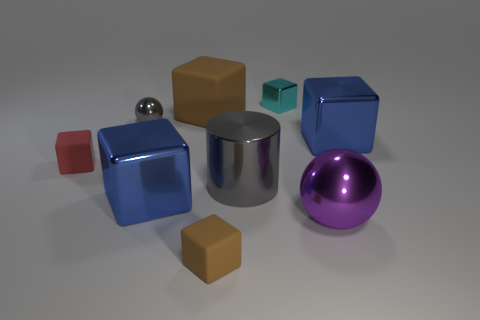Subtract all tiny metallic blocks. How many blocks are left? 5 Add 1 tiny cyan objects. How many objects exist? 10 Subtract all gray balls. How many balls are left? 1 Subtract 6 blocks. How many blocks are left? 0 Subtract all cylinders. How many objects are left? 8 Subtract all brown blocks. How many brown cylinders are left? 0 Subtract all large brown metallic spheres. Subtract all large purple objects. How many objects are left? 8 Add 6 big gray objects. How many big gray objects are left? 7 Add 2 small cyan matte cylinders. How many small cyan matte cylinders exist? 2 Subtract 0 yellow spheres. How many objects are left? 9 